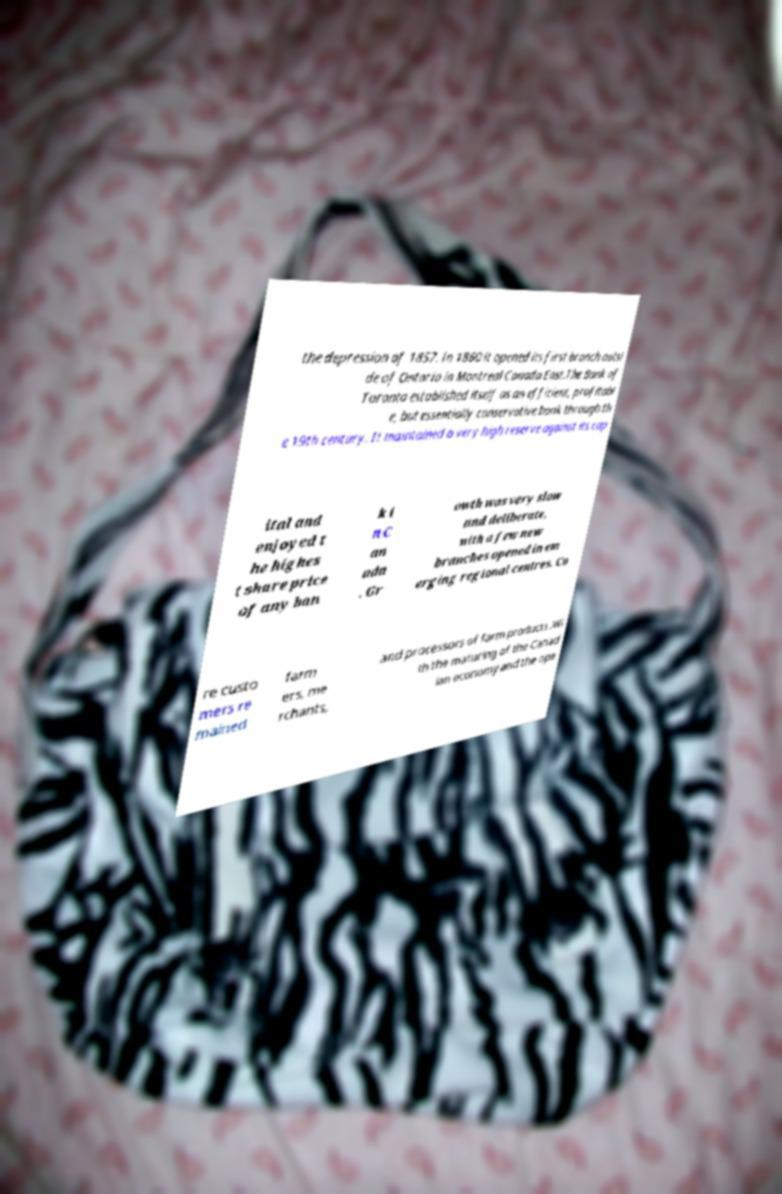Please identify and transcribe the text found in this image. the depression of 1857. In 1860 it opened its first branch outsi de of Ontario in Montreal Canada East.The Bank of Toronto established itself as an efficient, profitabl e, but essentially conservative bank through th e 19th century. It maintained a very high reserve against its cap ital and enjoyed t he highes t share price of any ban k i n C an ada . Gr owth was very slow and deliberate, with a few new branches opened in em erging regional centres. Co re custo mers re mained farm ers, me rchants, and processors of farm products .Wi th the maturing of the Canad ian economy and the ope 